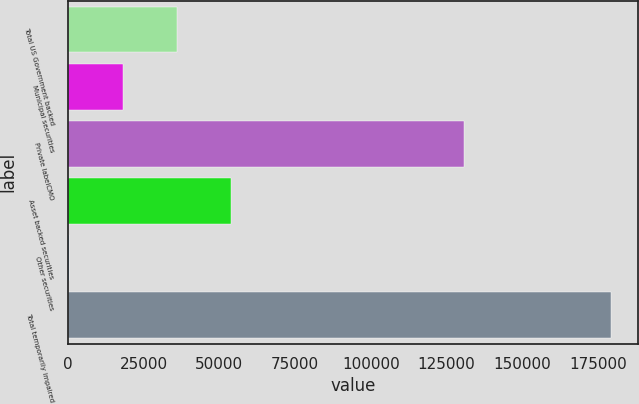<chart> <loc_0><loc_0><loc_500><loc_500><bar_chart><fcel>Total US Government backed<fcel>Municipal securities<fcel>Private labelCMO<fcel>Asset backed securities<fcel>Other securities<fcel>Total temporarily impaired<nl><fcel>36119.4<fcel>18221.2<fcel>130914<fcel>54017.6<fcel>323<fcel>179305<nl></chart> 